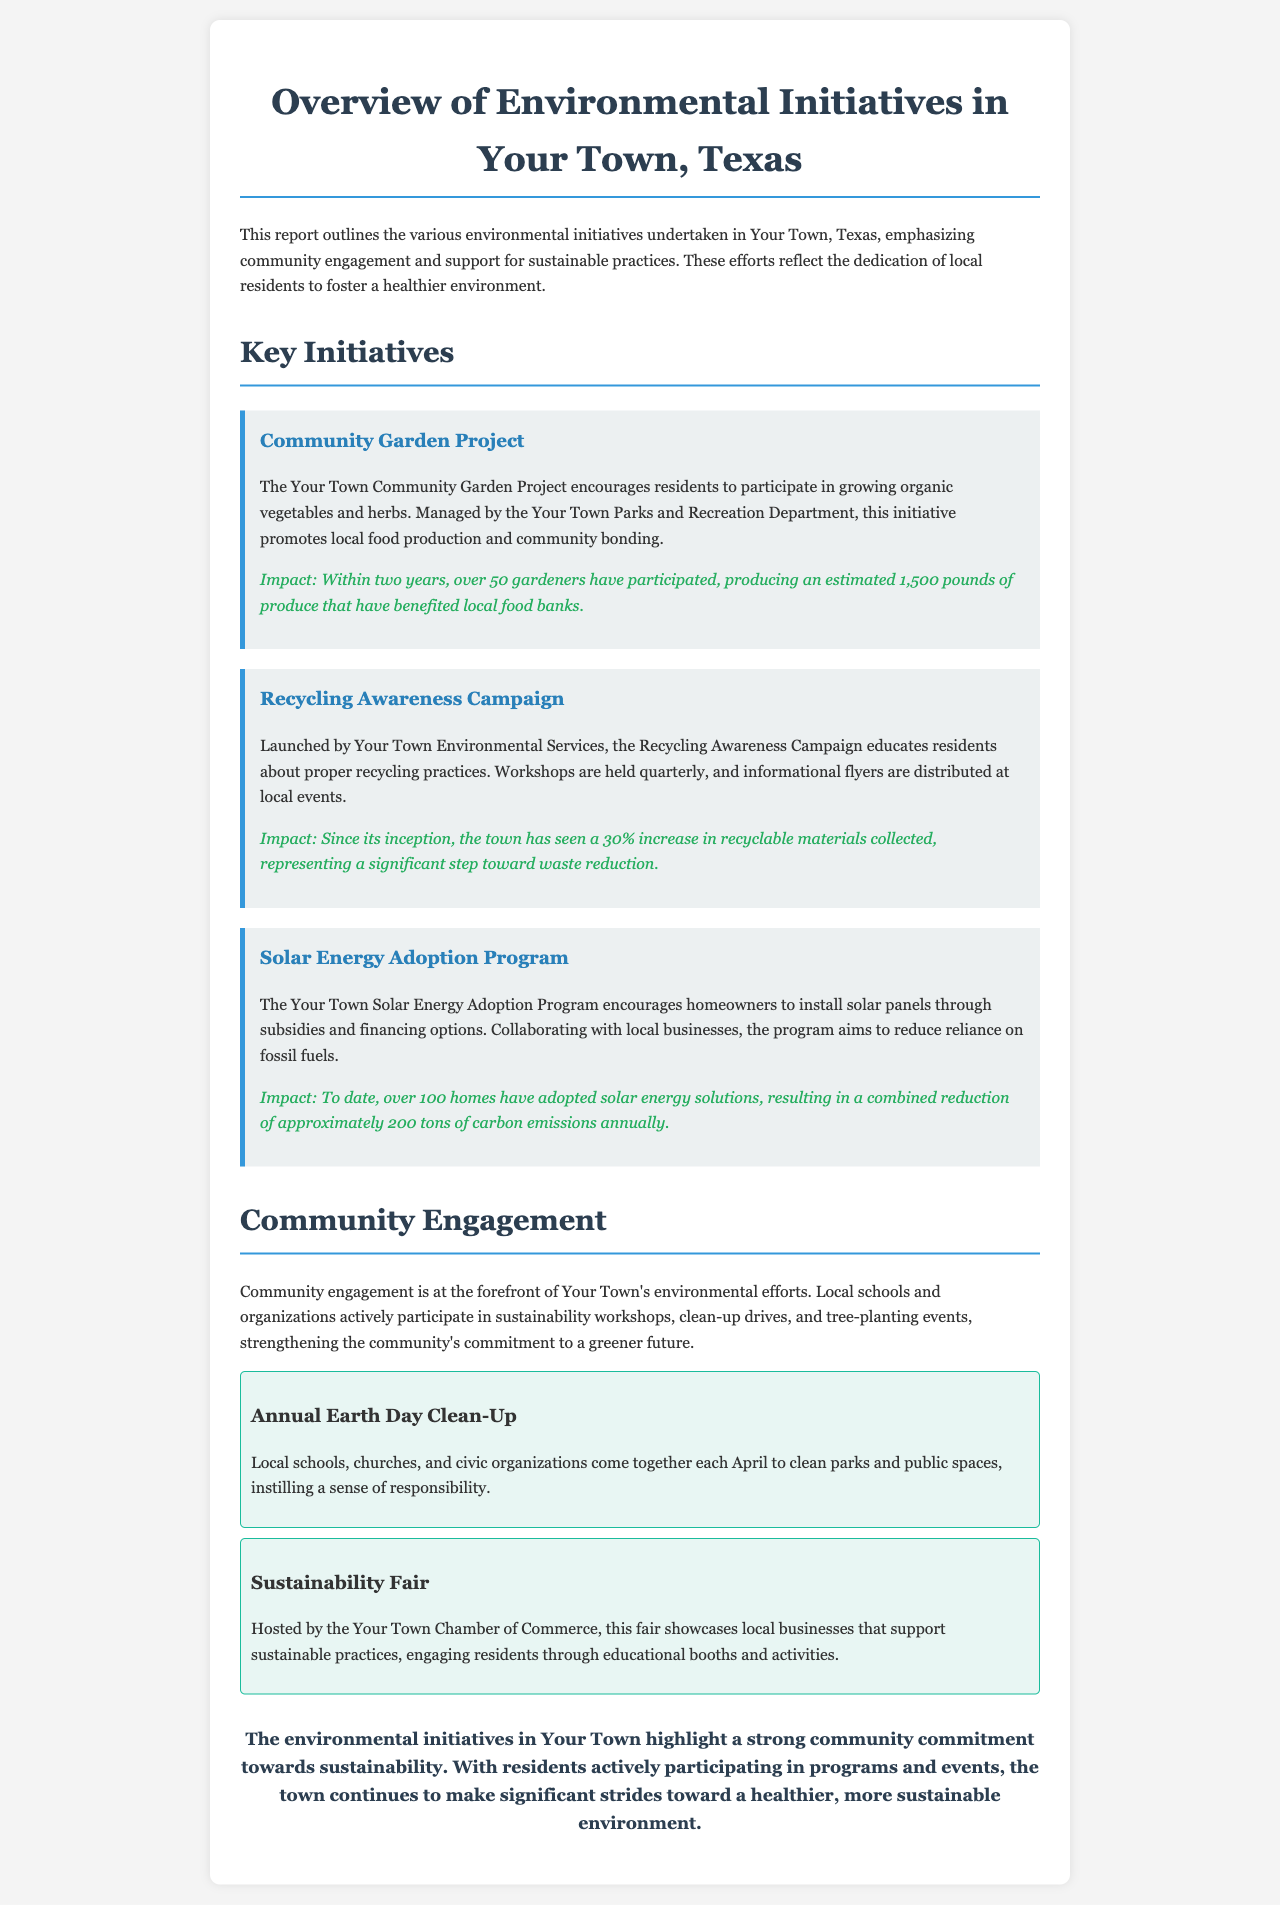what is the title of the report? The title of the report is provided in the header section, summarizing the content it covers.
Answer: Overview of Environmental Initiatives in Your Town, Texas how many pounds of produce have been produced by the Community Garden Project? This number is given in the impact section of the Community Garden Project description, reflecting the outcome of the initiative.
Answer: 1,500 pounds what is the impact of the Recycling Awareness Campaign? The impact indicates the result of the initiative, specifically highlighting the percentage increase in recyclables collected.
Answer: 30% how many homes have adopted solar energy solutions in Your Town? The number of homes adopting solar energy is explicitly stated in the description of the Solar Energy Adoption Program.
Answer: over 100 homes what community event takes place each April? The document specifies the time of the Annual Earth Day Clean-Up, indicating when this community effort occurs.
Answer: Annual Earth Day Clean-Up which department manages the Community Garden Project? The managing department of this project is mentioned in the initiative description.
Answer: Your Town Parks and Recreation Department what is the goal of the Solar Energy Adoption Program? The goal is explicitly mentioned in the description, emphasizing the motive behind the initiative.
Answer: reduce reliance on fossil fuels who hosts the Sustainability Fair? The organization responsible for hosting this event is clarified in the corresponding section of the document.
Answer: Your Town Chamber of Commerce 